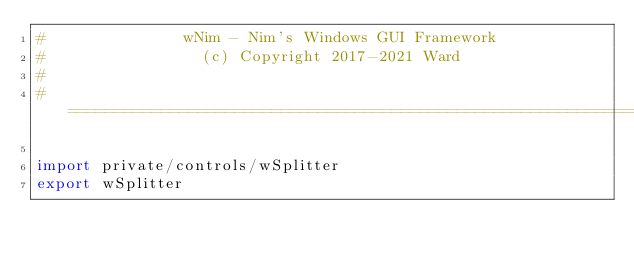Convert code to text. <code><loc_0><loc_0><loc_500><loc_500><_Nim_>#               wNim - Nim's Windows GUI Framework
#                 (c) Copyright 2017-2021 Ward
#
#====================================================================

import private/controls/wSplitter
export wSplitter
</code> 